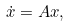<formula> <loc_0><loc_0><loc_500><loc_500>\dot { x } = A x ,</formula> 